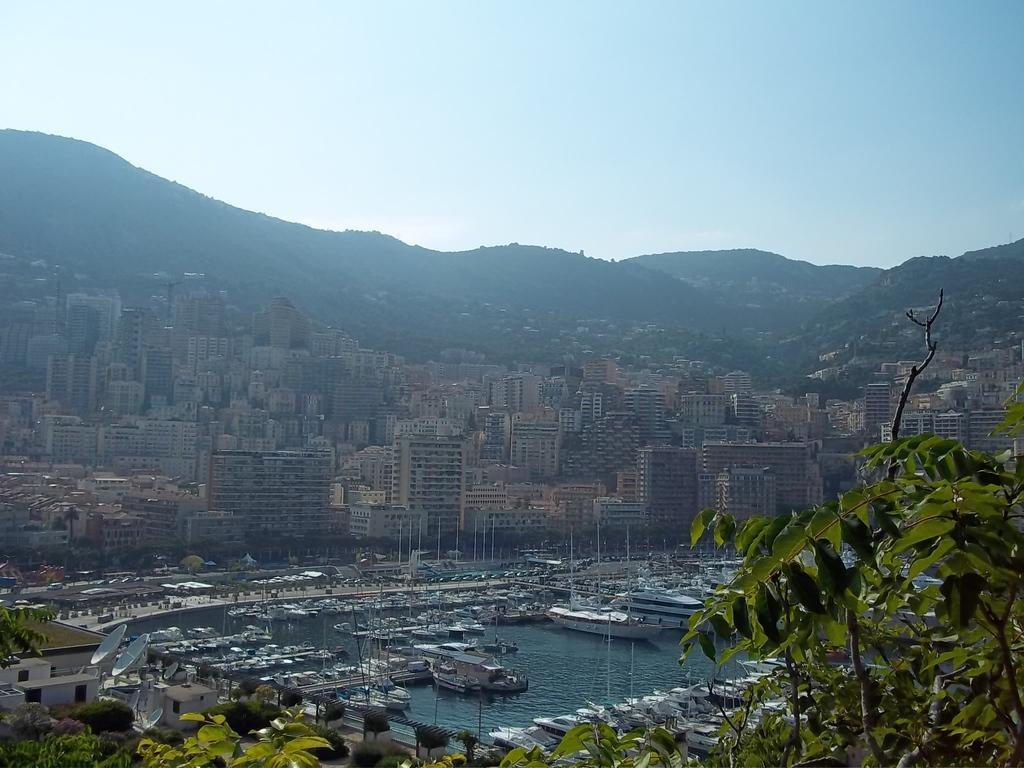In one or two sentences, can you explain what this image depicts? In this image I can see few boats on the water, they are in white color. Background I can see few buildings, trees in green color, mountains and the sky is in white color. 